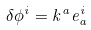<formula> <loc_0><loc_0><loc_500><loc_500>\delta \phi ^ { i } = k ^ { a } e ^ { i } _ { a }</formula> 